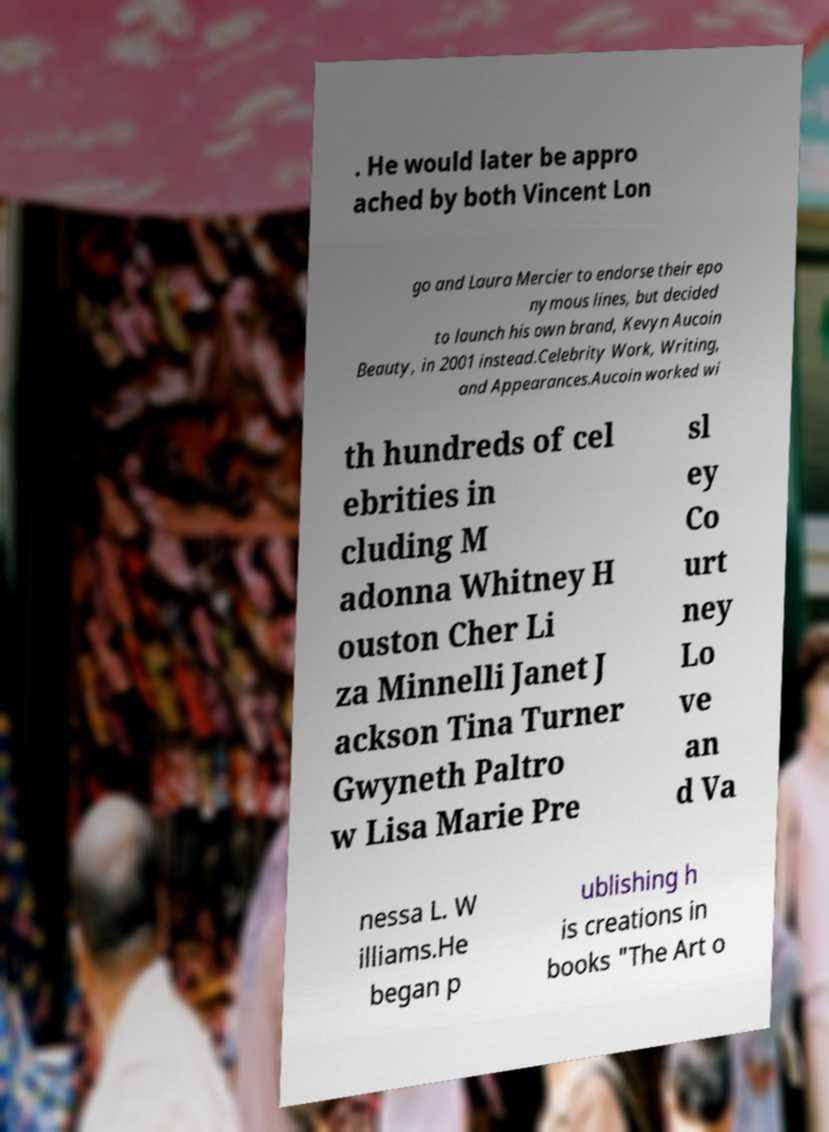Please read and relay the text visible in this image. What does it say? . He would later be appro ached by both Vincent Lon go and Laura Mercier to endorse their epo nymous lines, but decided to launch his own brand, Kevyn Aucoin Beauty, in 2001 instead.Celebrity Work, Writing, and Appearances.Aucoin worked wi th hundreds of cel ebrities in cluding M adonna Whitney H ouston Cher Li za Minnelli Janet J ackson Tina Turner Gwyneth Paltro w Lisa Marie Pre sl ey Co urt ney Lo ve an d Va nessa L. W illiams.He began p ublishing h is creations in books "The Art o 